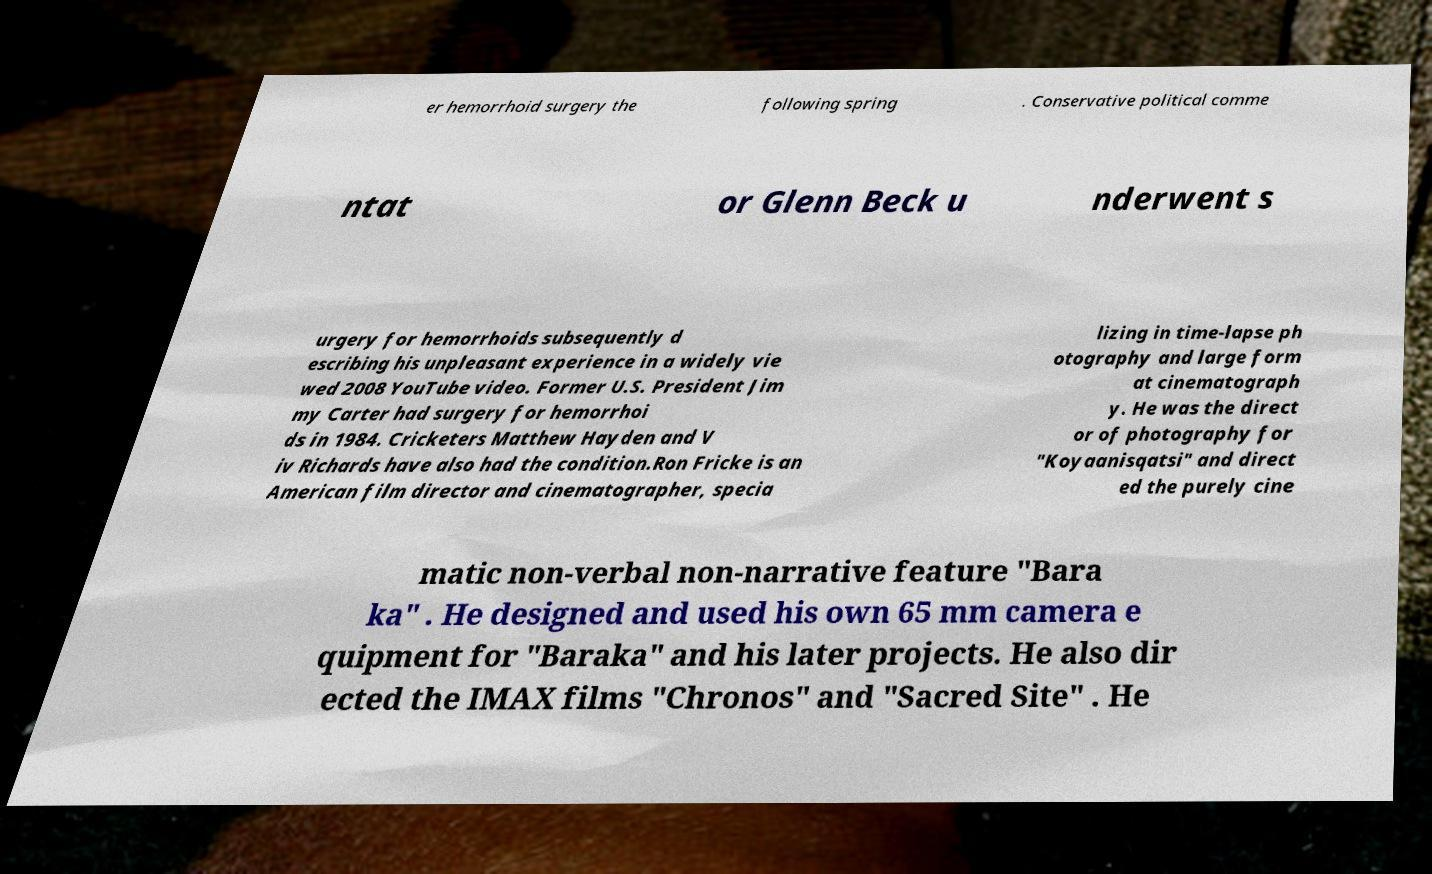For documentation purposes, I need the text within this image transcribed. Could you provide that? er hemorrhoid surgery the following spring . Conservative political comme ntat or Glenn Beck u nderwent s urgery for hemorrhoids subsequently d escribing his unpleasant experience in a widely vie wed 2008 YouTube video. Former U.S. President Jim my Carter had surgery for hemorrhoi ds in 1984. Cricketers Matthew Hayden and V iv Richards have also had the condition.Ron Fricke is an American film director and cinematographer, specia lizing in time-lapse ph otography and large form at cinematograph y. He was the direct or of photography for "Koyaanisqatsi" and direct ed the purely cine matic non-verbal non-narrative feature "Bara ka" . He designed and used his own 65 mm camera e quipment for "Baraka" and his later projects. He also dir ected the IMAX films "Chronos" and "Sacred Site" . He 